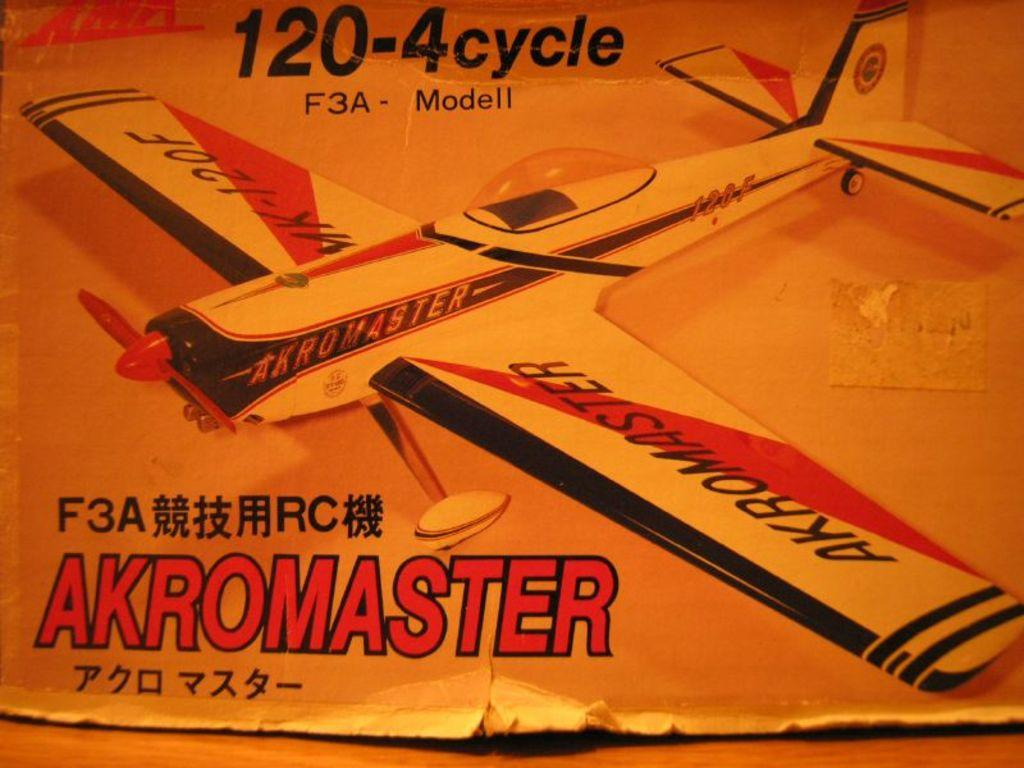<image>
Give a short and clear explanation of the subsequent image. A model plane with Akromaster on one of its wings. 